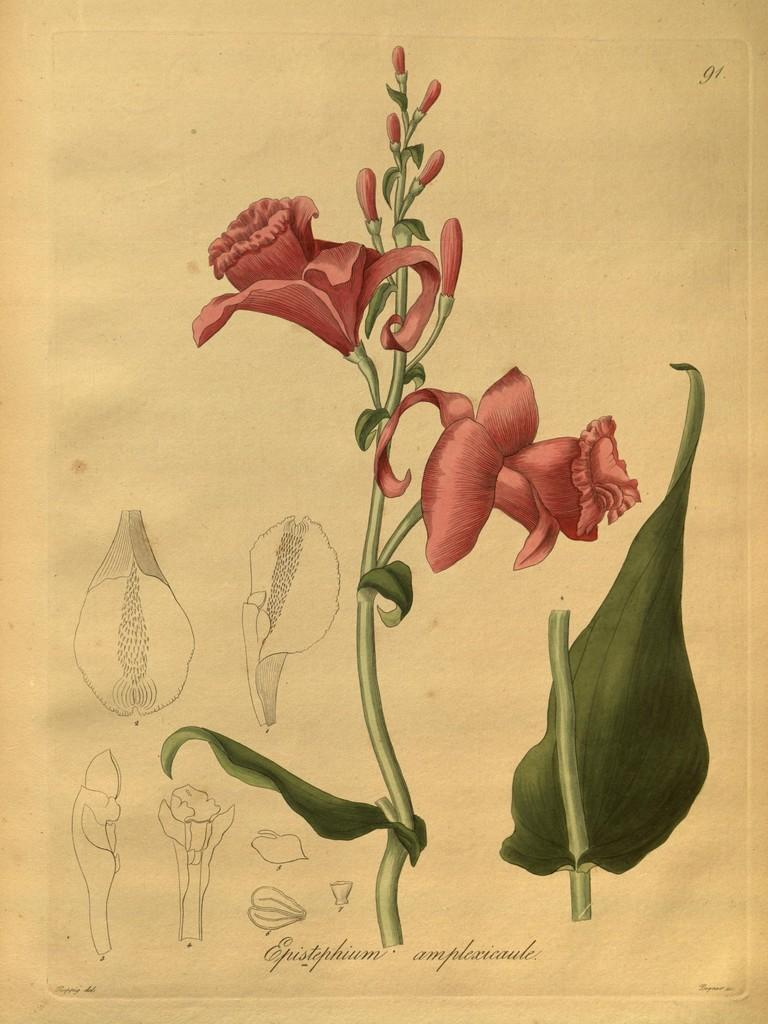What is depicted in the image? There is a drawing of flowers in the image. What other elements are present in the drawing? There are leaves in the drawing. How many pages are there in the drawing? The image is a drawing, not a book or document, so there are no pages present. 